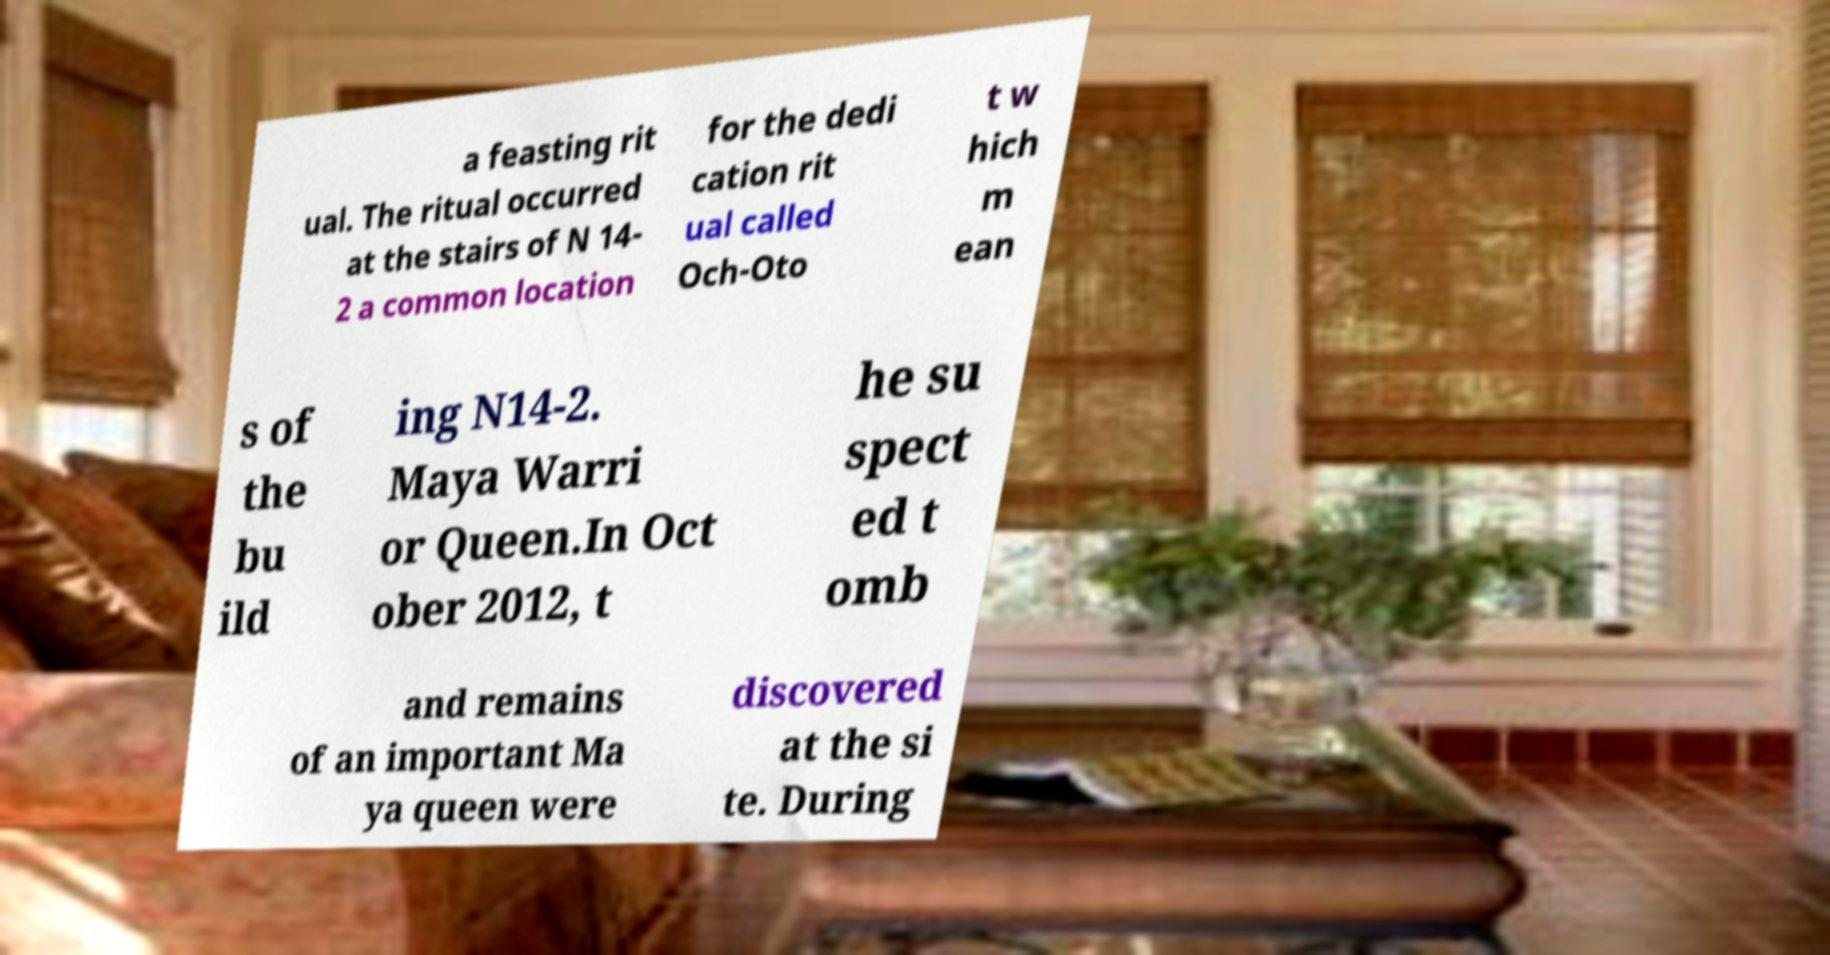Please read and relay the text visible in this image. What does it say? a feasting rit ual. The ritual occurred at the stairs of N 14- 2 a common location for the dedi cation rit ual called Och-Oto t w hich m ean s of the bu ild ing N14-2. Maya Warri or Queen.In Oct ober 2012, t he su spect ed t omb and remains of an important Ma ya queen were discovered at the si te. During 